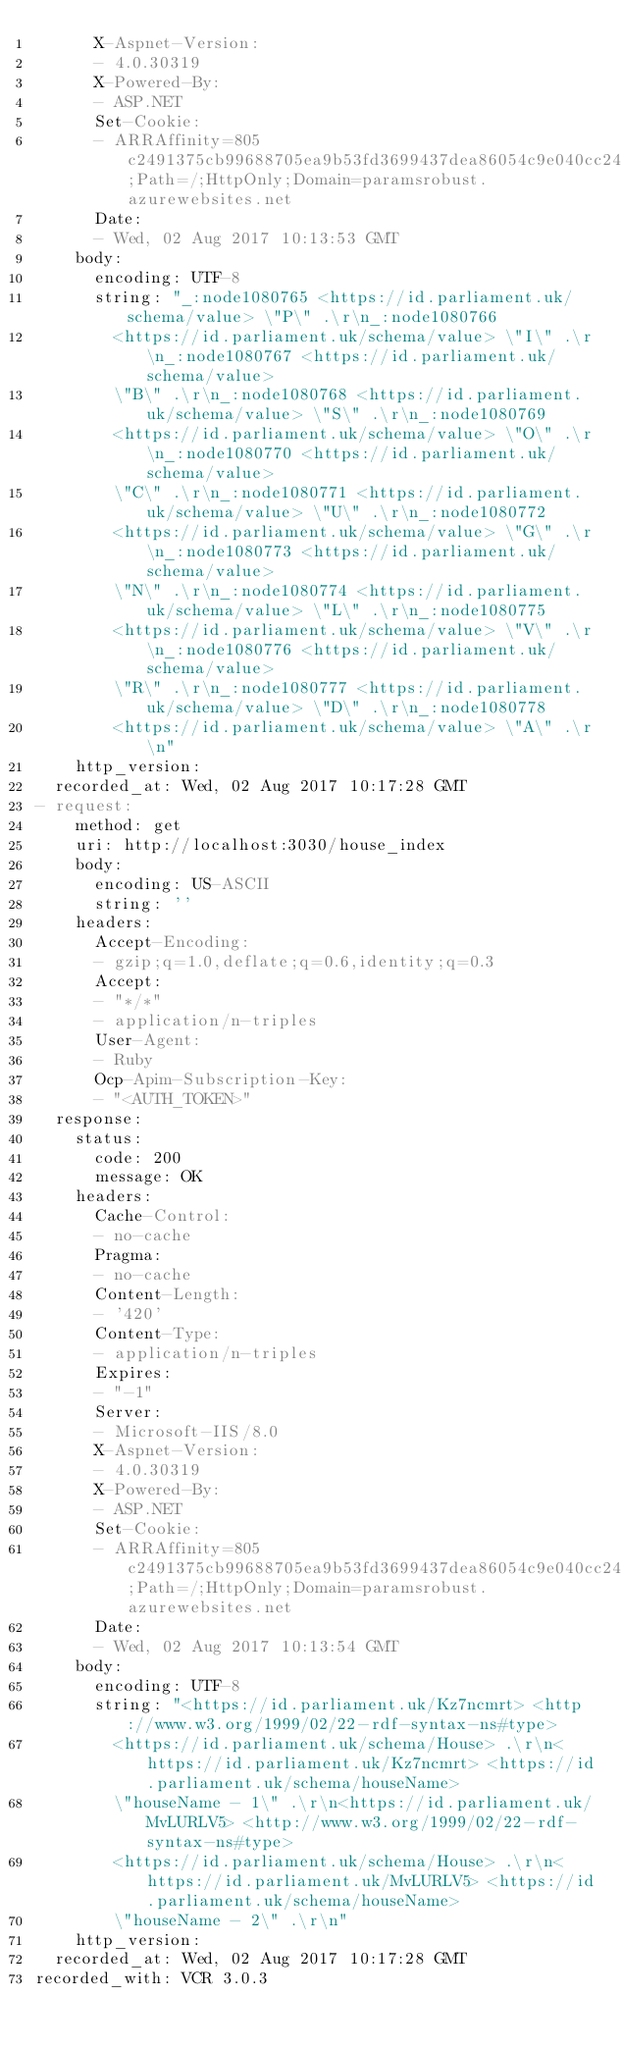Convert code to text. <code><loc_0><loc_0><loc_500><loc_500><_YAML_>      X-Aspnet-Version:
      - 4.0.30319
      X-Powered-By:
      - ASP.NET
      Set-Cookie:
      - ARRAffinity=805c2491375cb99688705ea9b53fd3699437dea86054c9e040cc24406d1ad374;Path=/;HttpOnly;Domain=paramsrobust.azurewebsites.net
      Date:
      - Wed, 02 Aug 2017 10:13:53 GMT
    body:
      encoding: UTF-8
      string: "_:node1080765 <https://id.parliament.uk/schema/value> \"P\" .\r\n_:node1080766
        <https://id.parliament.uk/schema/value> \"I\" .\r\n_:node1080767 <https://id.parliament.uk/schema/value>
        \"B\" .\r\n_:node1080768 <https://id.parliament.uk/schema/value> \"S\" .\r\n_:node1080769
        <https://id.parliament.uk/schema/value> \"O\" .\r\n_:node1080770 <https://id.parliament.uk/schema/value>
        \"C\" .\r\n_:node1080771 <https://id.parliament.uk/schema/value> \"U\" .\r\n_:node1080772
        <https://id.parliament.uk/schema/value> \"G\" .\r\n_:node1080773 <https://id.parliament.uk/schema/value>
        \"N\" .\r\n_:node1080774 <https://id.parliament.uk/schema/value> \"L\" .\r\n_:node1080775
        <https://id.parliament.uk/schema/value> \"V\" .\r\n_:node1080776 <https://id.parliament.uk/schema/value>
        \"R\" .\r\n_:node1080777 <https://id.parliament.uk/schema/value> \"D\" .\r\n_:node1080778
        <https://id.parliament.uk/schema/value> \"A\" .\r\n"
    http_version:
  recorded_at: Wed, 02 Aug 2017 10:17:28 GMT
- request:
    method: get
    uri: http://localhost:3030/house_index
    body:
      encoding: US-ASCII
      string: ''
    headers:
      Accept-Encoding:
      - gzip;q=1.0,deflate;q=0.6,identity;q=0.3
      Accept:
      - "*/*"
      - application/n-triples
      User-Agent:
      - Ruby
      Ocp-Apim-Subscription-Key:
      - "<AUTH_TOKEN>"
  response:
    status:
      code: 200
      message: OK
    headers:
      Cache-Control:
      - no-cache
      Pragma:
      - no-cache
      Content-Length:
      - '420'
      Content-Type:
      - application/n-triples
      Expires:
      - "-1"
      Server:
      - Microsoft-IIS/8.0
      X-Aspnet-Version:
      - 4.0.30319
      X-Powered-By:
      - ASP.NET
      Set-Cookie:
      - ARRAffinity=805c2491375cb99688705ea9b53fd3699437dea86054c9e040cc24406d1ad374;Path=/;HttpOnly;Domain=paramsrobust.azurewebsites.net
      Date:
      - Wed, 02 Aug 2017 10:13:54 GMT
    body:
      encoding: UTF-8
      string: "<https://id.parliament.uk/Kz7ncmrt> <http://www.w3.org/1999/02/22-rdf-syntax-ns#type>
        <https://id.parliament.uk/schema/House> .\r\n<https://id.parliament.uk/Kz7ncmrt> <https://id.parliament.uk/schema/houseName>
        \"houseName - 1\" .\r\n<https://id.parliament.uk/MvLURLV5> <http://www.w3.org/1999/02/22-rdf-syntax-ns#type>
        <https://id.parliament.uk/schema/House> .\r\n<https://id.parliament.uk/MvLURLV5> <https://id.parliament.uk/schema/houseName>
        \"houseName - 2\" .\r\n"
    http_version:
  recorded_at: Wed, 02 Aug 2017 10:17:28 GMT
recorded_with: VCR 3.0.3
</code> 